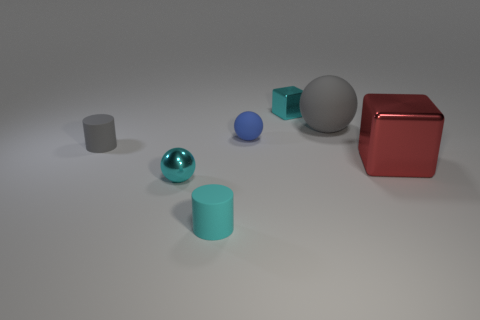There is a cyan matte thing; how many gray matte objects are left of it?
Provide a succinct answer. 1. Are there fewer big rubber objects in front of the large gray ball than cyan spheres left of the red metallic cube?
Provide a short and direct response. Yes. How many tiny gray things are there?
Give a very brief answer. 1. What color is the thing that is left of the cyan ball?
Your response must be concise. Gray. The cyan shiny block has what size?
Make the answer very short. Small. There is a big metallic block; does it have the same color as the tiny metallic thing behind the tiny cyan metal sphere?
Provide a succinct answer. No. The tiny cylinder that is in front of the large thing right of the big matte ball is what color?
Offer a very short reply. Cyan. Is the shape of the gray matte object in front of the large rubber object the same as  the tiny cyan rubber object?
Keep it short and to the point. Yes. How many tiny things are behind the big gray rubber ball and in front of the tiny cube?
Make the answer very short. 0. What color is the rubber cylinder that is right of the small cyan metal thing that is in front of the cube right of the large gray rubber sphere?
Provide a short and direct response. Cyan. 